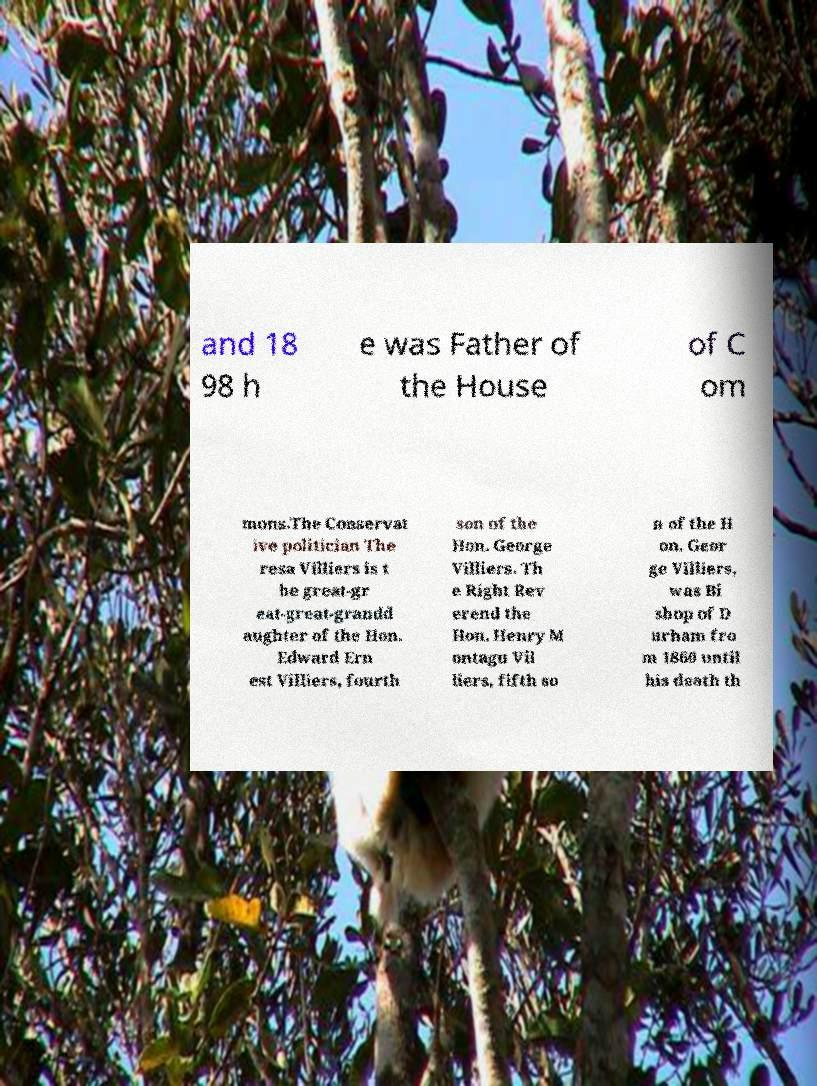Could you extract and type out the text from this image? and 18 98 h e was Father of the House of C om mons.The Conservat ive politician The resa Villiers is t he great-gr eat-great-grandd aughter of the Hon. Edward Ern est Villiers, fourth son of the Hon. George Villiers. Th e Right Rev erend the Hon. Henry M ontagu Vil liers, fifth so n of the H on. Geor ge Villiers, was Bi shop of D urham fro m 1860 until his death th 